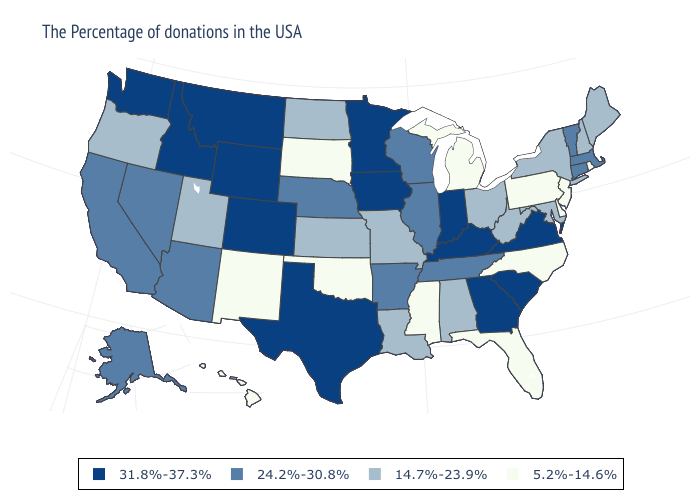Does New Mexico have the lowest value in the West?
Concise answer only. Yes. Does Florida have the highest value in the USA?
Quick response, please. No. Does the map have missing data?
Quick response, please. No. Name the states that have a value in the range 5.2%-14.6%?
Keep it brief. Rhode Island, New Jersey, Delaware, Pennsylvania, North Carolina, Florida, Michigan, Mississippi, Oklahoma, South Dakota, New Mexico, Hawaii. Does Maryland have the lowest value in the USA?
Give a very brief answer. No. Among the states that border Mississippi , does Arkansas have the highest value?
Answer briefly. Yes. What is the value of Washington?
Quick response, please. 31.8%-37.3%. What is the highest value in the South ?
Keep it brief. 31.8%-37.3%. Which states have the highest value in the USA?
Give a very brief answer. Virginia, South Carolina, Georgia, Kentucky, Indiana, Minnesota, Iowa, Texas, Wyoming, Colorado, Montana, Idaho, Washington. Among the states that border West Virginia , which have the lowest value?
Quick response, please. Pennsylvania. Does the first symbol in the legend represent the smallest category?
Short answer required. No. What is the lowest value in states that border Virginia?
Answer briefly. 5.2%-14.6%. Name the states that have a value in the range 5.2%-14.6%?
Answer briefly. Rhode Island, New Jersey, Delaware, Pennsylvania, North Carolina, Florida, Michigan, Mississippi, Oklahoma, South Dakota, New Mexico, Hawaii. 